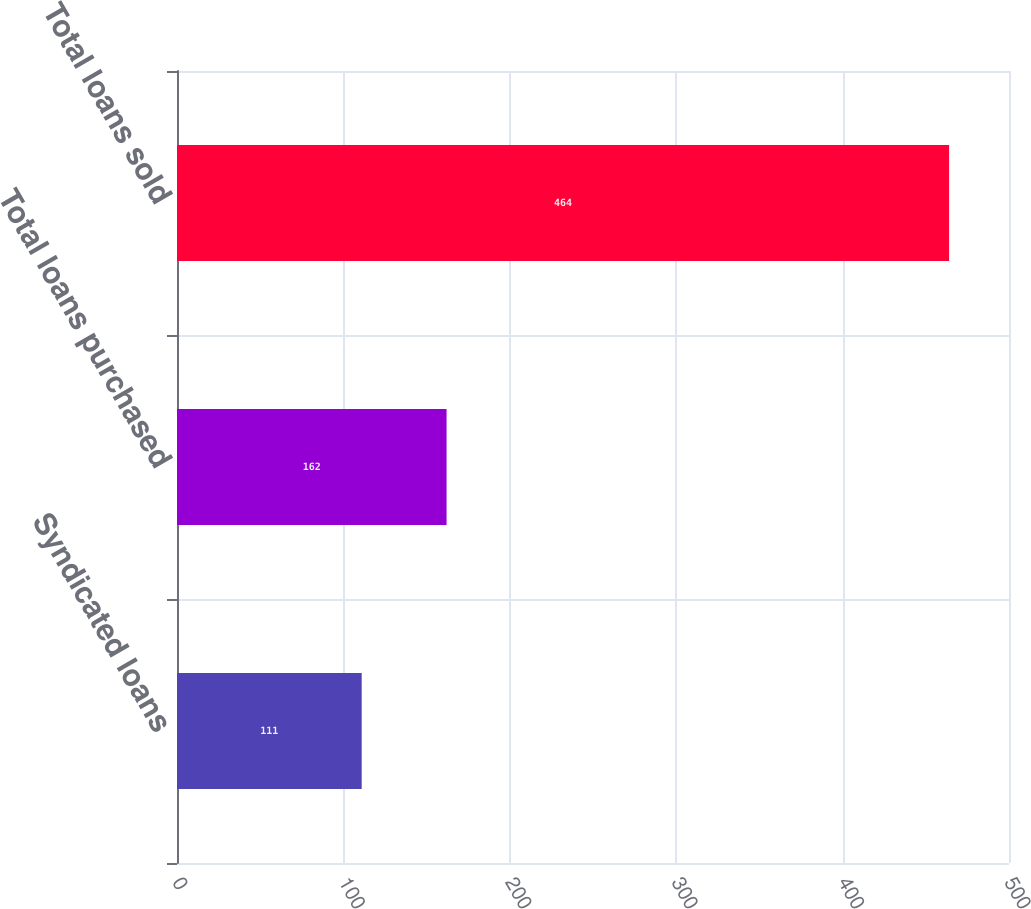Convert chart. <chart><loc_0><loc_0><loc_500><loc_500><bar_chart><fcel>Syndicated loans<fcel>Total loans purchased<fcel>Total loans sold<nl><fcel>111<fcel>162<fcel>464<nl></chart> 